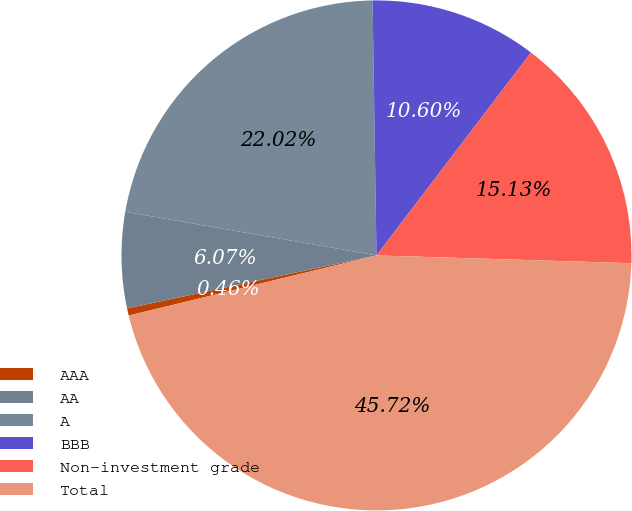<chart> <loc_0><loc_0><loc_500><loc_500><pie_chart><fcel>AAA<fcel>AA<fcel>A<fcel>BBB<fcel>Non-investment grade<fcel>Total<nl><fcel>0.46%<fcel>6.07%<fcel>22.02%<fcel>10.6%<fcel>15.13%<fcel>45.72%<nl></chart> 